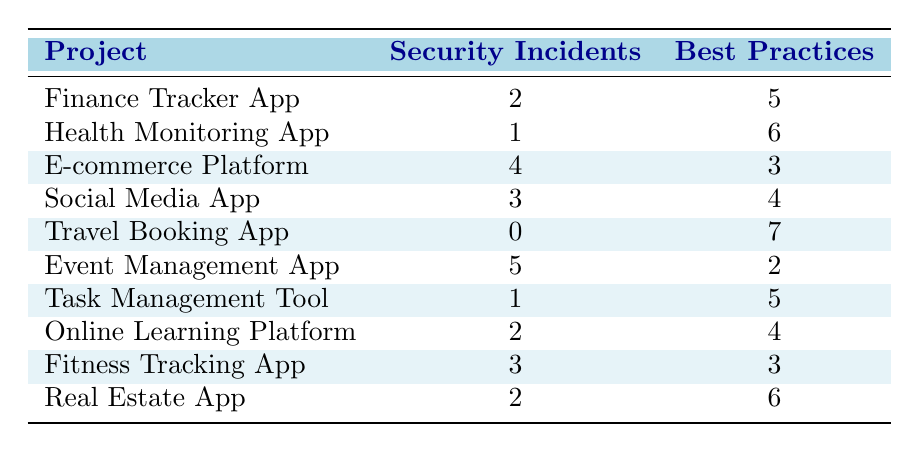What is the project with the highest number of security incidents? The maximum value in the "Security Incidents" column is 5, which corresponds to the "Event Management App."
Answer: Event Management App How many best practices were implemented in the Travel Booking App? Looking at the "Best Practices" column for the Travel Booking App, it shows a value of 7.
Answer: 7 Is it true that the E-commerce Platform implemented more best practices than the Fitness Tracking App? The E-commerce Platform has 3 best practices while the Fitness Tracking App has 3 as well, so they are equal. Thus, the statement is false.
Answer: No What is the average number of security incidents across all projects? To calculate the average, first, sum up all the values in the "Security Incidents" column: 2 + 1 + 4 + 3 + 0 + 5 + 1 + 2 + 3 + 2 = 23. There are 10 projects, so the average is 23 / 10 = 2.3.
Answer: 2.3 Which project has the lowest frequency of security incidents, and how many incidents did it have? The lowest value in the "Security Incidents" column is 0, which is associated with the "Travel Booking App."
Answer: Travel Booking App, 0 How many projects had exactly 2 best practices implemented? By inspecting the "Best Practices" column, there are two projects: the Event Management App (2) and the E-commerce Platform (3). Therefore, only one project has 2 best practices implemented.
Answer: 1 Is there a project that had security incidents but did not implement any best practices? Every project listed has some best practices implemented. The minimum number of best practices is 2, so the statement is false.
Answer: No What is the total number of best practices implemented across all applications? Adding all values in the "Best Practices" column: 5 + 6 + 3 + 4 + 7 + 2 + 5 + 4 + 3 + 6 = 45.
Answer: 45 How many projects have more than three security incidents? Observing the "Security Incidents" column, the projects that have more than three incidents are: E-commerce Platform (4) and Event Management App (5). Thus, there are two such projects.
Answer: 2 